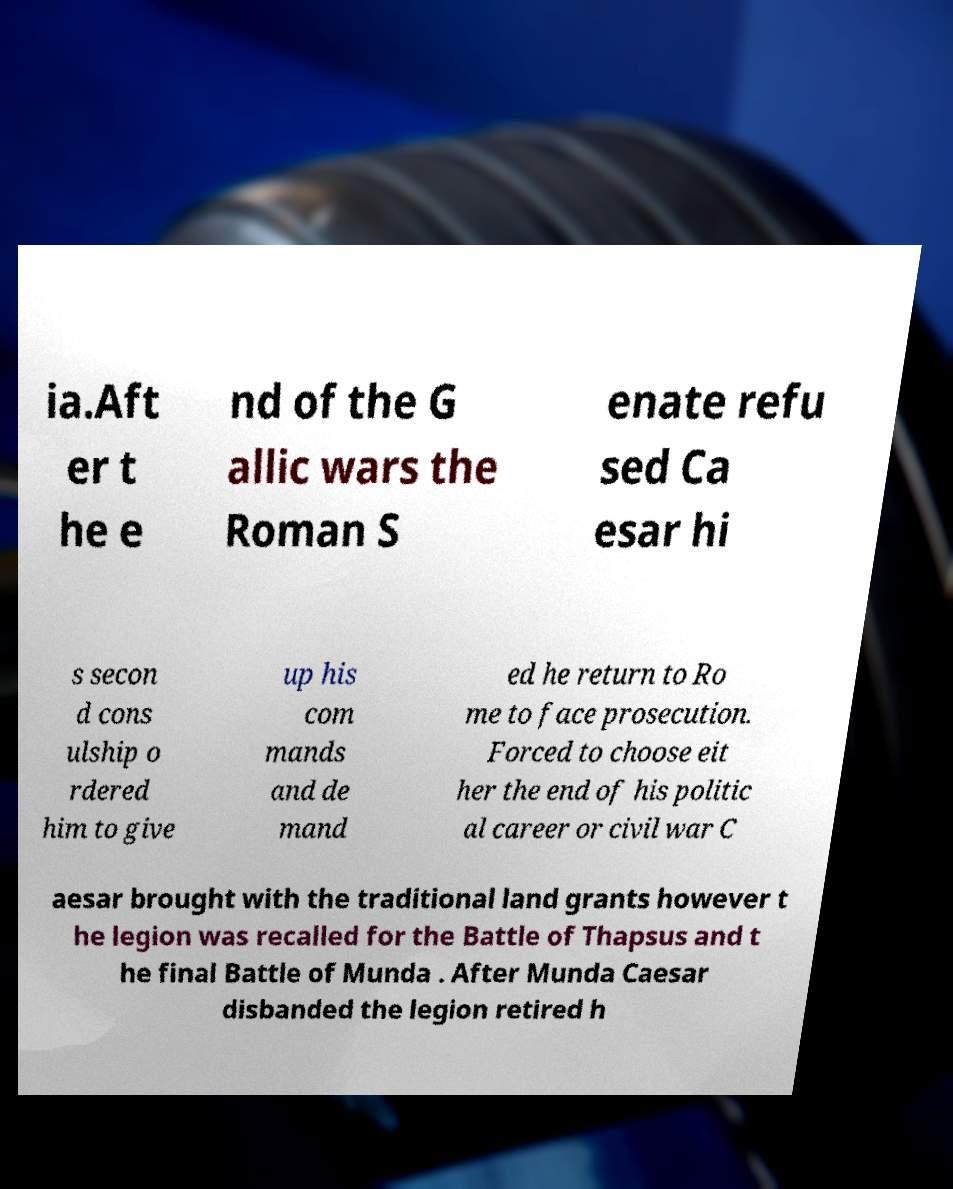For documentation purposes, I need the text within this image transcribed. Could you provide that? ia.Aft er t he e nd of the G allic wars the Roman S enate refu sed Ca esar hi s secon d cons ulship o rdered him to give up his com mands and de mand ed he return to Ro me to face prosecution. Forced to choose eit her the end of his politic al career or civil war C aesar brought with the traditional land grants however t he legion was recalled for the Battle of Thapsus and t he final Battle of Munda . After Munda Caesar disbanded the legion retired h 